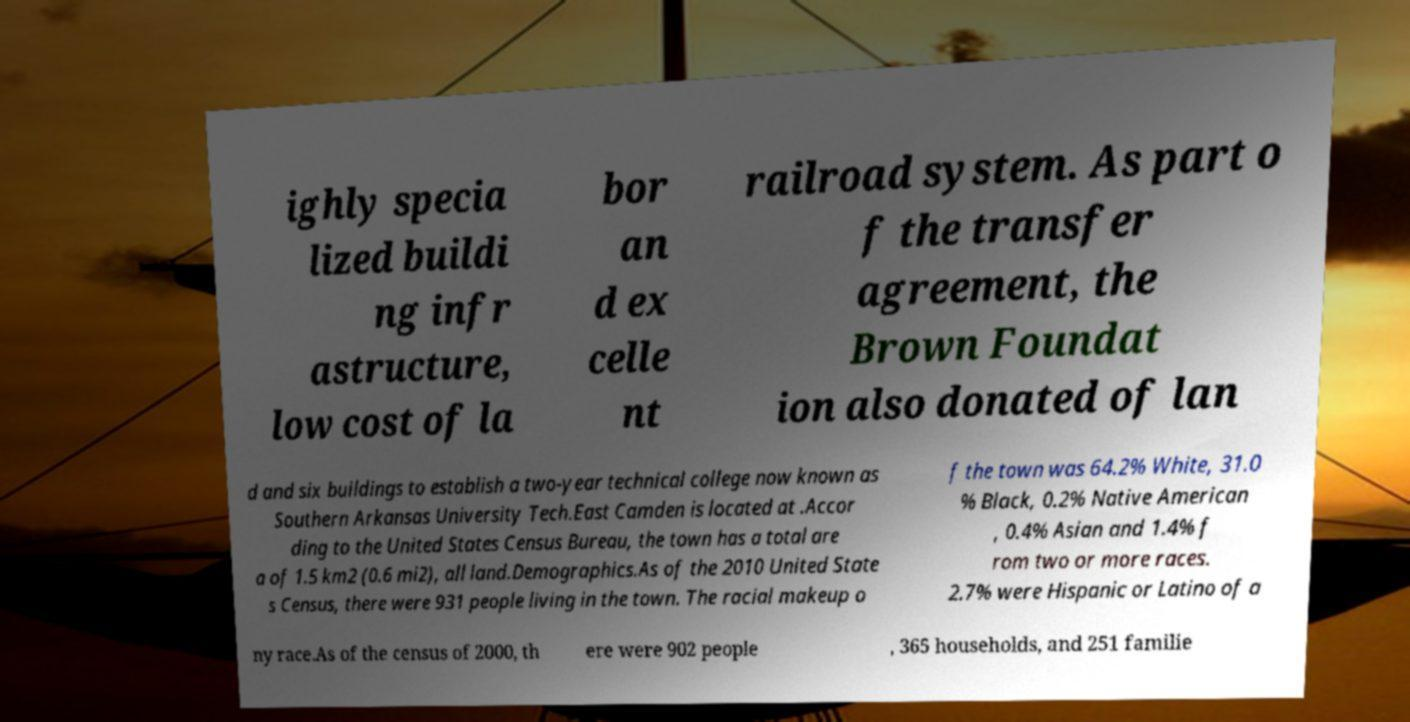Can you accurately transcribe the text from the provided image for me? ighly specia lized buildi ng infr astructure, low cost of la bor an d ex celle nt railroad system. As part o f the transfer agreement, the Brown Foundat ion also donated of lan d and six buildings to establish a two-year technical college now known as Southern Arkansas University Tech.East Camden is located at .Accor ding to the United States Census Bureau, the town has a total are a of 1.5 km2 (0.6 mi2), all land.Demographics.As of the 2010 United State s Census, there were 931 people living in the town. The racial makeup o f the town was 64.2% White, 31.0 % Black, 0.2% Native American , 0.4% Asian and 1.4% f rom two or more races. 2.7% were Hispanic or Latino of a ny race.As of the census of 2000, th ere were 902 people , 365 households, and 251 familie 